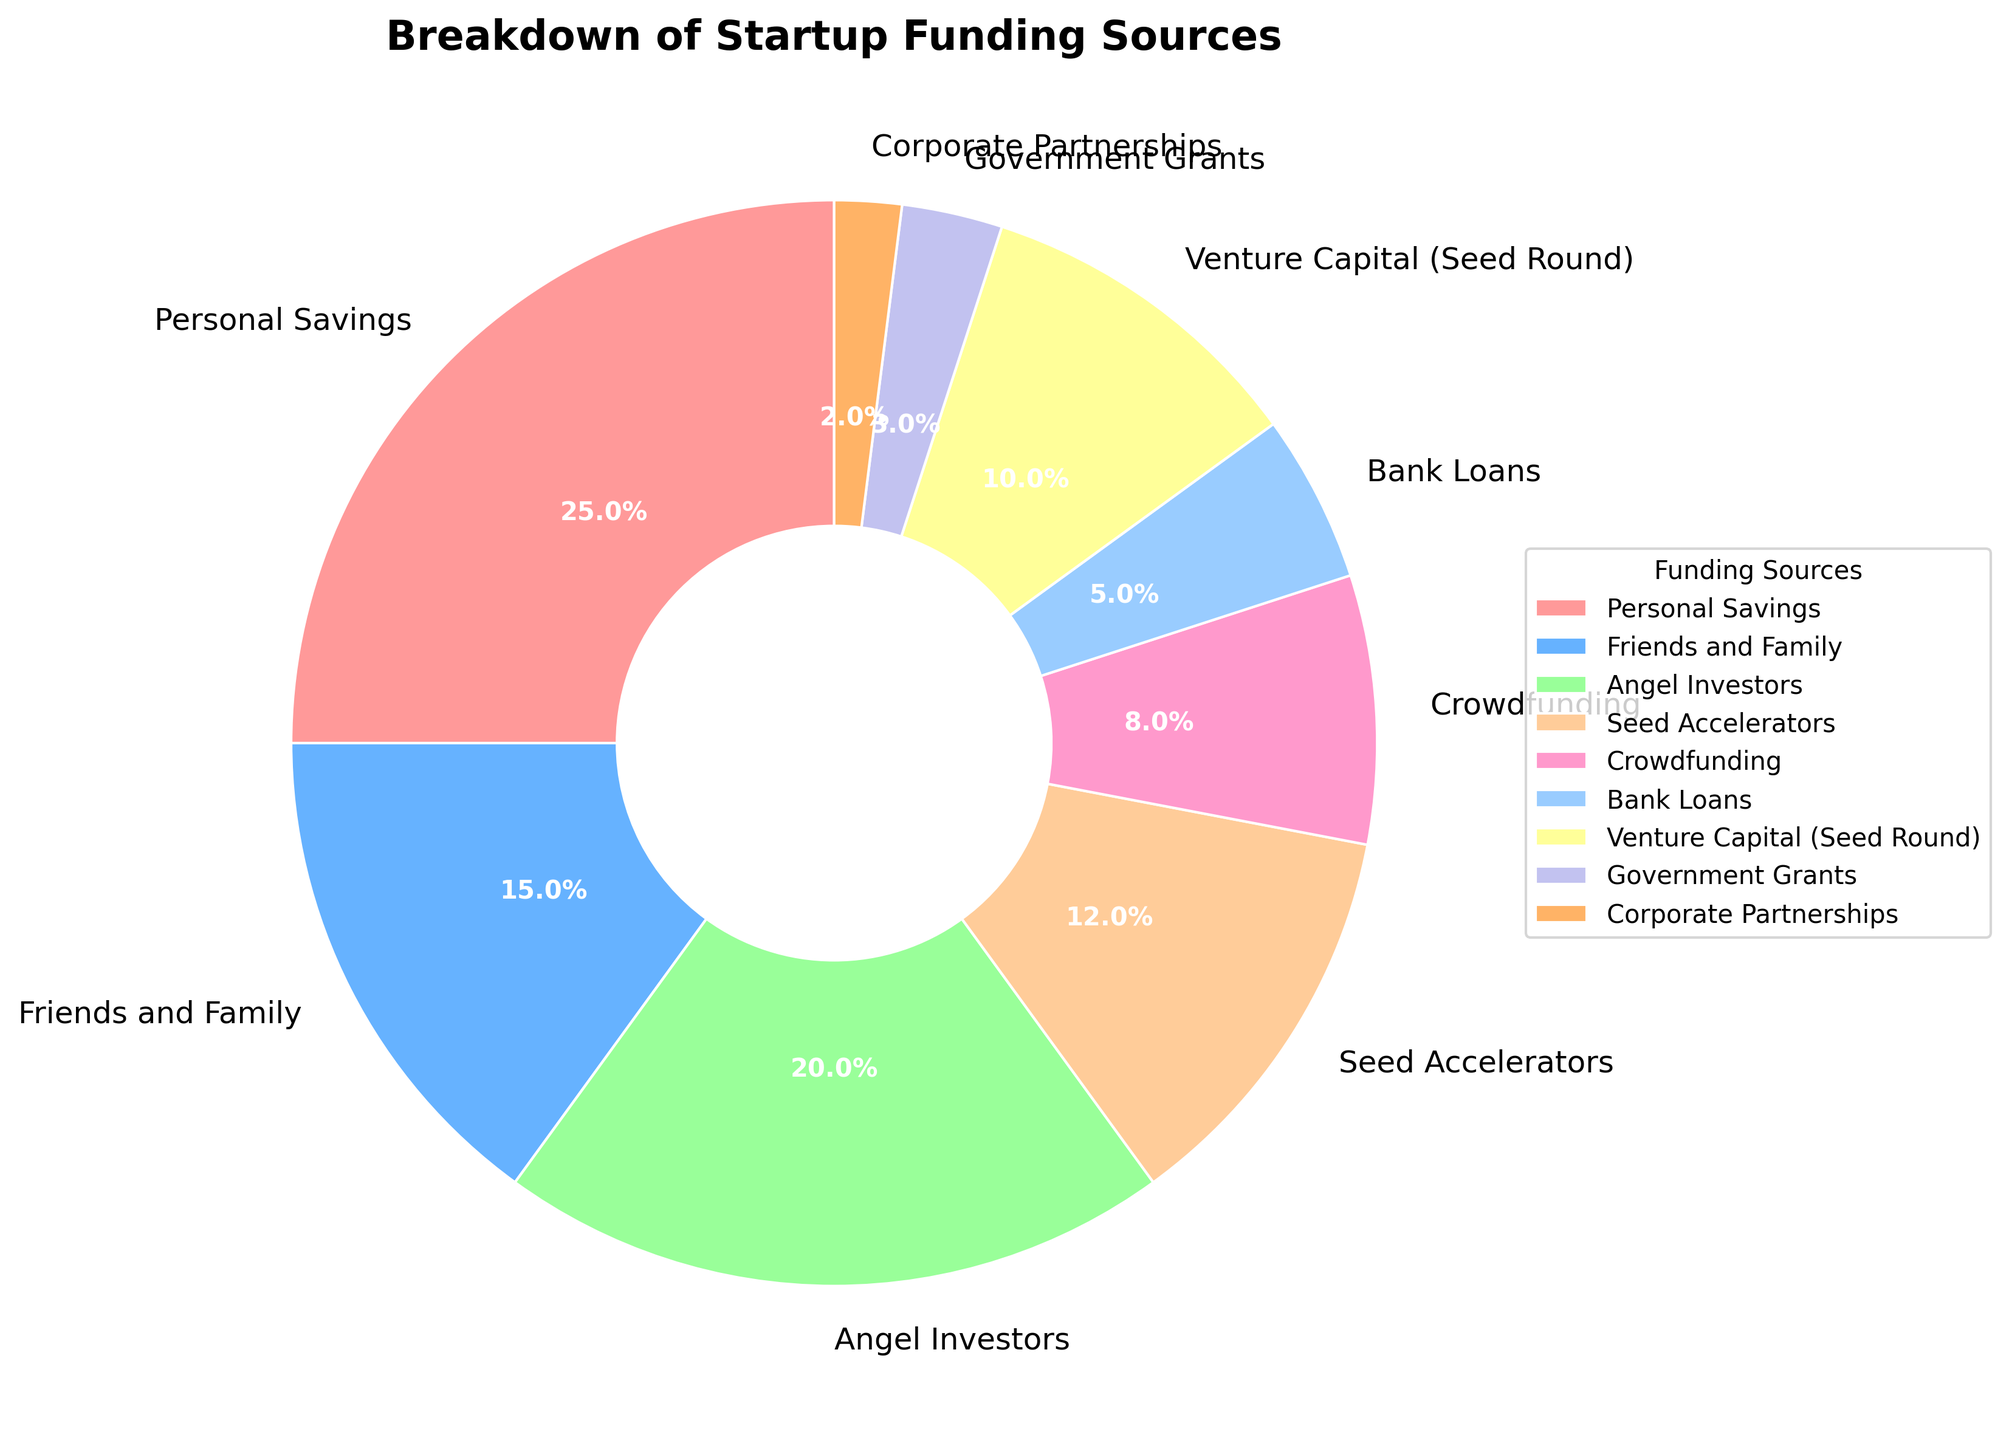What is the largest funding source for early-stage startups according to the pie chart? The largest funding source can be identified by looking for the segment with the highest percentage. Personal Savings has the largest slice, indicating it is the largest funding source.
Answer: Personal Savings Which funding source has a smaller percentage, Crowdfunding or Bank Loans? Compare the sizes of the segments for Crowdfunding and Bank Loans. Crowdfunding has a larger slice (8%) compared to Bank Loans (5%). Therefore, Bank Loans has a smaller percentage.
Answer: Bank Loans What is the combined percentage for Angel Investors and Venture Capital (Seed Round)? To find the combined percentage, add the percentages for Angel Investors (20%) and Venture Capital (Seed Round) (10%). The total is 20% + 10% = 30%.
Answer: 30% Which funding source occupies a darker shade of blue, Friends and Family or Venture Capital (Seed Round)? By observing the color shades, Friends and Family is associated with a lighter shade of blue, while Venture Capital (Seed Round) is indicated by a darker shade of blue.
Answer: Venture Capital (Seed Round) Is the percentage of Government Grants greater than that of Corporate Partnerships? Compare the percentage slices for Government Grants (3%) and Corporate Partnerships (2%). Government Grants has a larger segment.
Answer: Yes What is the difference in percentage between Personal Savings and Seed Accelerators? Subtract the percentage of Seed Accelerators (12%) from Personal Savings (25%). The difference is 25% - 12% = 13%.
Answer: 13% What is the median value of the percentages of all funding sources? Arrange the percentages in ascending order: 2, 3, 5, 8, 10, 12, 15, 20, 25. Since there are 9 values, the median is the fifth value when sorted, which is 10 (Venture Capital (Seed Round)).
Answer: 10 Which two funding sources combined have the same percentage as Personal Savings? We need two segments that add up to 25%. Friends and Family (15%) and Seed Accelerators (12%) together total 27%, which is too high. However, Angel Investors (20%) and Bank Loans (5%) together sum to 25%.
Answer: Angel Investors and Bank Loans 